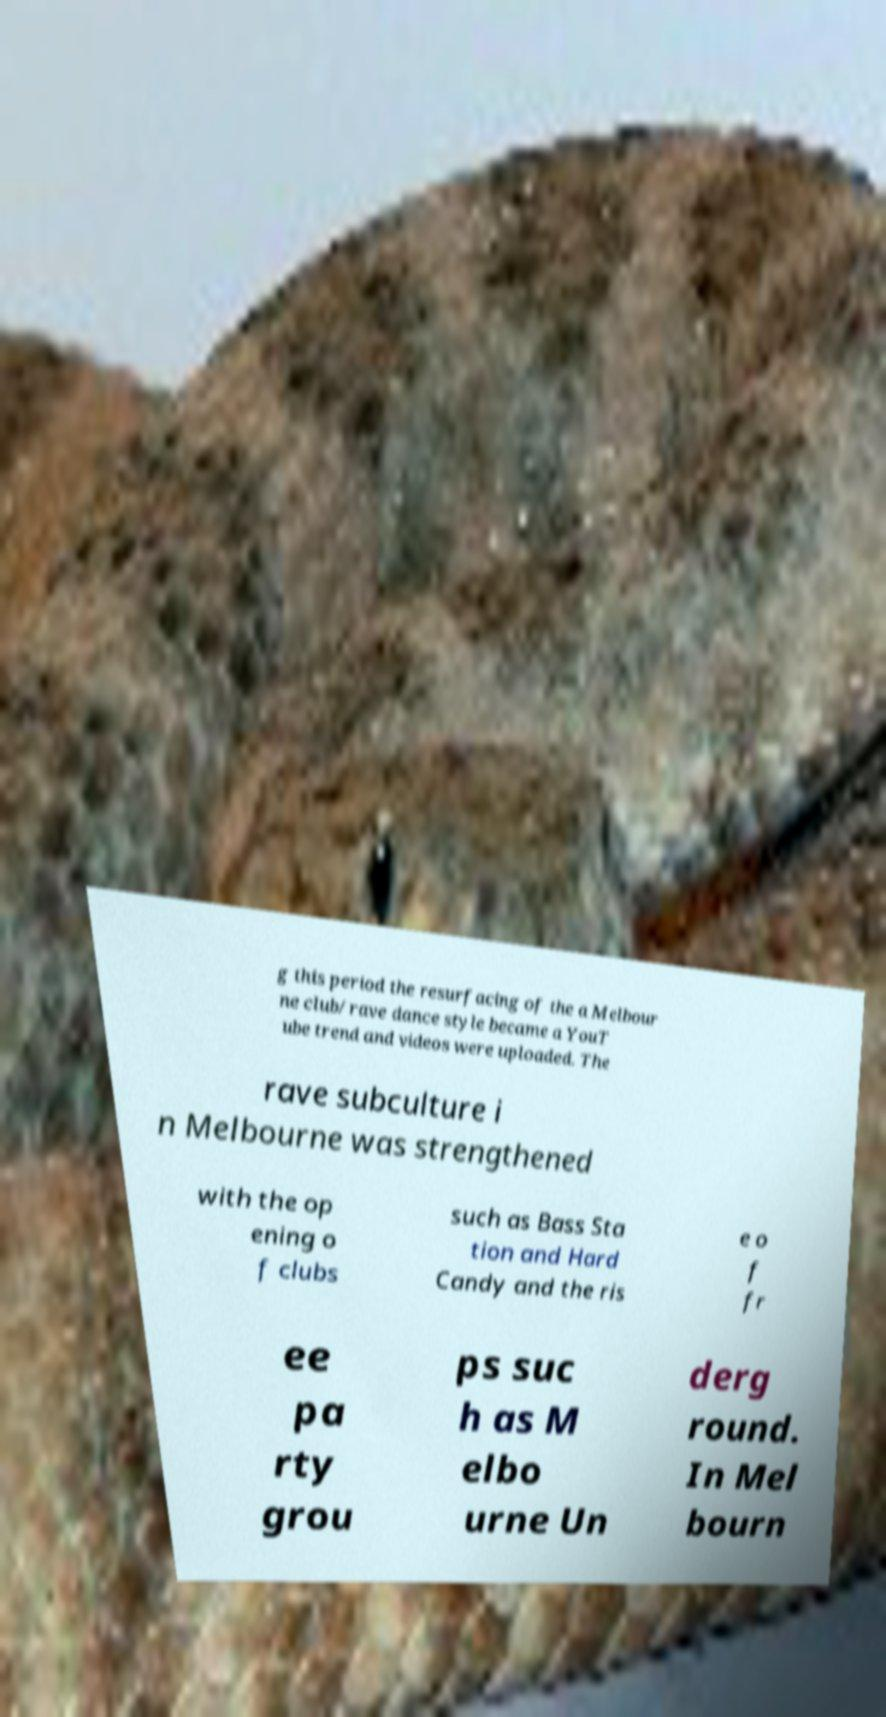Please read and relay the text visible in this image. What does it say? g this period the resurfacing of the a Melbour ne club/rave dance style became a YouT ube trend and videos were uploaded. The rave subculture i n Melbourne was strengthened with the op ening o f clubs such as Bass Sta tion and Hard Candy and the ris e o f fr ee pa rty grou ps suc h as M elbo urne Un derg round. In Mel bourn 